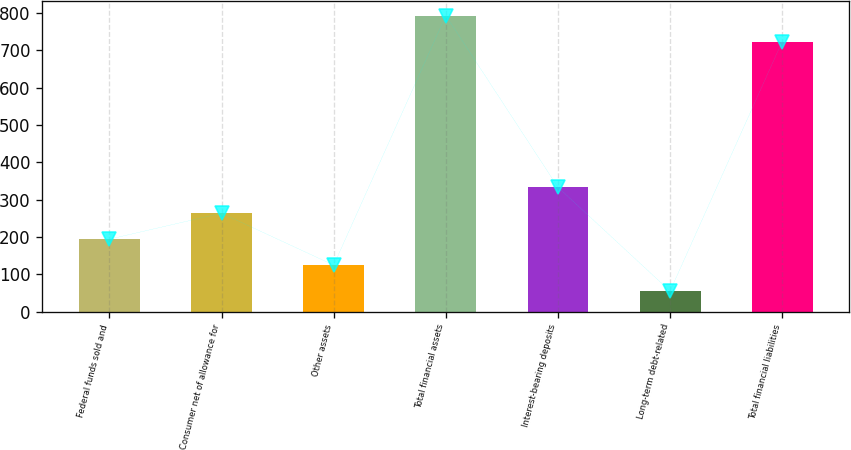Convert chart to OTSL. <chart><loc_0><loc_0><loc_500><loc_500><bar_chart><fcel>Federal funds sold and<fcel>Consumer net of allowance for<fcel>Other assets<fcel>Total financial assets<fcel>Interest-bearing deposits<fcel>Long-term debt-related<fcel>Total financial liabilities<nl><fcel>193.98<fcel>263.57<fcel>124.39<fcel>793.19<fcel>333.16<fcel>54.8<fcel>723.6<nl></chart> 